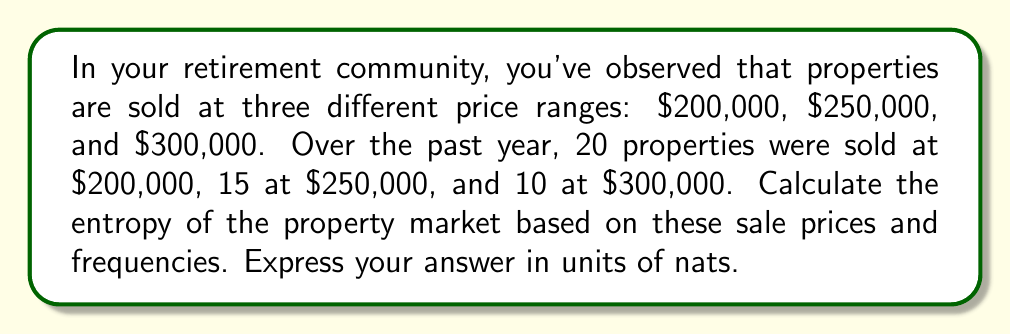Show me your answer to this math problem. To calculate the entropy of the property market, we'll use the Shannon entropy formula:

$$S = -\sum_{i} p_i \ln(p_i)$$

Where $p_i$ is the probability of each outcome.

Step 1: Calculate the total number of properties sold.
Total properties = 20 + 15 + 10 = 45

Step 2: Calculate the probabilities for each price range.
$p_1 = 20/45 = 4/9$ (for $200,000)
$p_2 = 15/45 = 1/3$ (for $250,000)
$p_3 = 10/45 = 2/9$ (for $300,000)

Step 3: Apply the entropy formula.
$$\begin{align}
S &= -\left(\frac{4}{9} \ln\left(\frac{4}{9}\right) + \frac{1}{3} \ln\left(\frac{1}{3}\right) + \frac{2}{9} \ln\left(\frac{2}{9}\right)\right) \\
&= -\left(\frac{4}{9} \cdot (-0.8109) + \frac{1}{3} \cdot (-1.0986) + \frac{2}{9} \cdot (-1.5041)\right) \\
&= 0.3604 + 0.3662 + 0.3342 \\
&= 1.0608 \text{ nats}
\end{align}$$
Answer: 1.0608 nats 